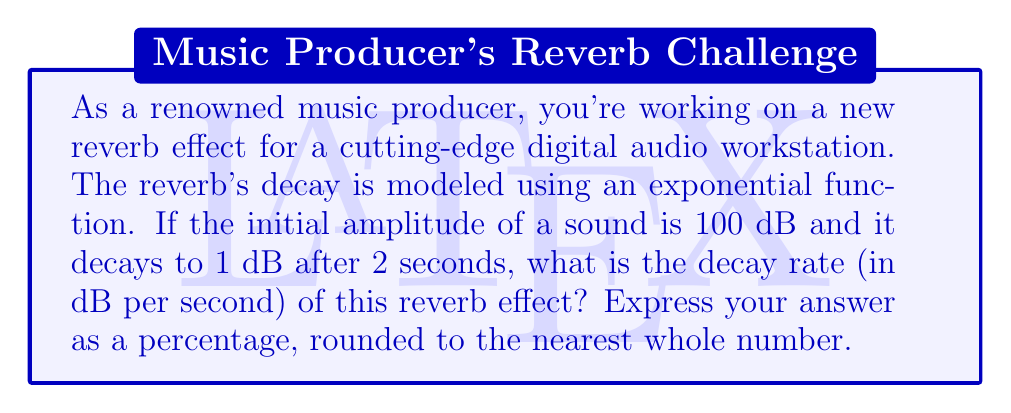Help me with this question. Let's approach this step-by-step:

1) The exponential decay function can be modeled as:

   $A(t) = A_0 e^{-kt}$

   Where $A(t)$ is the amplitude at time $t$, $A_0$ is the initial amplitude, $k$ is the decay constant, and $t$ is time.

2) We're given:
   $A_0 = 100$ dB
   $A(2) = 1$ dB
   $t = 2$ seconds

3) Let's plug these into our equation:

   $1 = 100 e^{-2k}$

4) Divide both sides by 100:

   $\frac{1}{100} = e^{-2k}$

5) Take the natural log of both sides:

   $\ln(\frac{1}{100}) = -2k$

6) Simplify:

   $-4.605 = -2k$

7) Solve for $k$:

   $k = \frac{4.605}{2} = 2.3025$

8) The decay rate in dB per second is $k \times 100\%$:

   $2.3025 \times 100\% = 230.25\%$

9) Rounding to the nearest whole number:

   $230\%$

This means the sound level decreases by 230% of its current value each second.
Answer: 230% 